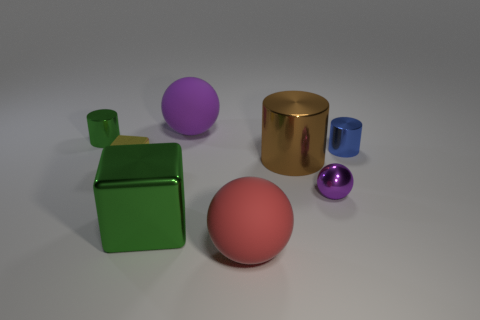What is the material of the purple sphere that is to the right of the brown metal cylinder to the right of the sphere that is in front of the green cube?
Your answer should be very brief. Metal. Is the block on the right side of the small yellow metallic object made of the same material as the ball behind the big brown metallic thing?
Keep it short and to the point. No. There is a metal object that is behind the large brown object and to the right of the tiny yellow shiny block; how big is it?
Give a very brief answer. Small. There is a sphere that is the same size as the green metal cylinder; what is its material?
Provide a succinct answer. Metal. What number of small blue objects are behind the green object that is in front of the yellow shiny block to the right of the tiny green cylinder?
Make the answer very short. 1. Do the shiny block in front of the yellow metallic cube and the small shiny cylinder to the left of the metallic sphere have the same color?
Offer a very short reply. Yes. The tiny metal object that is both on the right side of the tiny cube and in front of the tiny blue cylinder is what color?
Keep it short and to the point. Purple. What number of cubes have the same size as the purple matte thing?
Make the answer very short. 1. There is a large purple thing that is right of the green object that is in front of the small blue metallic thing; what shape is it?
Provide a succinct answer. Sphere. What shape is the green object that is to the right of the shiny cylinder on the left side of the big ball that is in front of the green metal block?
Your response must be concise. Cube. 